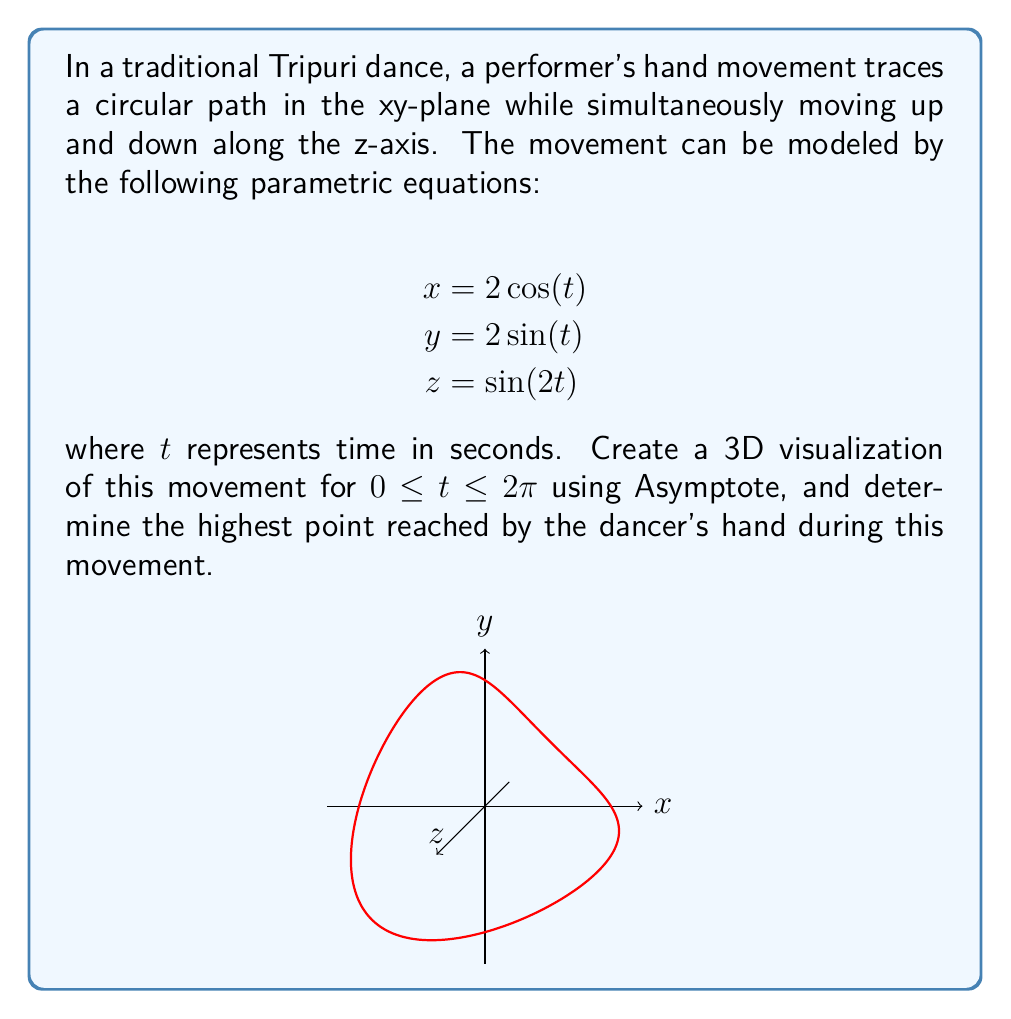Can you answer this question? To solve this problem, we need to follow these steps:

1) The z-coordinate represents the vertical position of the dancer's hand. To find the highest point, we need to maximize the z-equation.

2) The z-equation is given by:
   $$z = \sin(2t)$$

3) We know that the sine function reaches its maximum value of 1 when its argument is $\frac{\pi}{2} + 2\pi n$, where n is any integer.

4) So, we need to solve:
   $$2t = \frac{\pi}{2} + 2\pi n$$

5) The smallest positive solution in our range $0 \leq t \leq 2\pi$ is when $n = 0$:
   $$2t = \frac{\pi}{2}$$
   $$t = \frac{\pi}{4}$$

6) At this time $t = \frac{\pi}{4}$, the z-coordinate reaches its maximum value:
   $$z_{max} = \sin(2 \cdot \frac{\pi}{4}) = \sin(\frac{\pi}{2}) = 1$$

7) Therefore, the highest point reached by the dancer's hand is 1 unit above the xy-plane.
Answer: 1 unit 